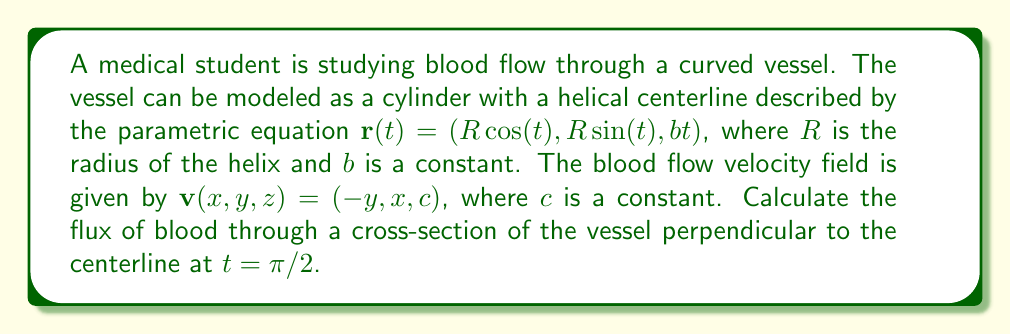What is the answer to this math problem? Let's approach this step-by-step:

1) First, we need to find the normal vector to the cross-section. This is given by the tangent vector to the centerline at $t = \pi/2$:

   $$\mathbf{T}(\pi/2) = \frac{d\mathbf{r}}{dt}(\pi/2) = (-R\sin(\pi/2), R\cos(\pi/2), b) = (-R, 0, b)$$

2) Normalize this vector:

   $$\mathbf{n} = \frac{(-R, 0, b)}{\sqrt{R^2 + b^2}}$$

3) The area vector of the cross-section is $\mathbf{A} = \pi r^2 \mathbf{n}$, where $r$ is the radius of the vessel.

4) The flux is given by the dot product of the velocity field and the area vector:

   $$\text{Flux} = \mathbf{v} \cdot \mathbf{A} = \pi r^2 \mathbf{v} \cdot \mathbf{n}$$

5) At $t = \pi/2$, the position on the centerline is $(0, R, b\pi/2)$. The velocity field at this point is:

   $$\mathbf{v}(0, R, b\pi/2) = (-R, 0, c)$$

6) Now we can calculate the dot product:

   $$\mathbf{v} \cdot \mathbf{n} = \frac{(-R, 0, c) \cdot (-R, 0, b)}{\sqrt{R^2 + b^2}} = \frac{R^2 + bc}{\sqrt{R^2 + b^2}}$$

7) Therefore, the flux is:

   $$\text{Flux} = \pi r^2 \frac{R^2 + bc}{\sqrt{R^2 + b^2}}$$
Answer: $$\pi r^2 \frac{R^2 + bc}{\sqrt{R^2 + b^2}}$$ 